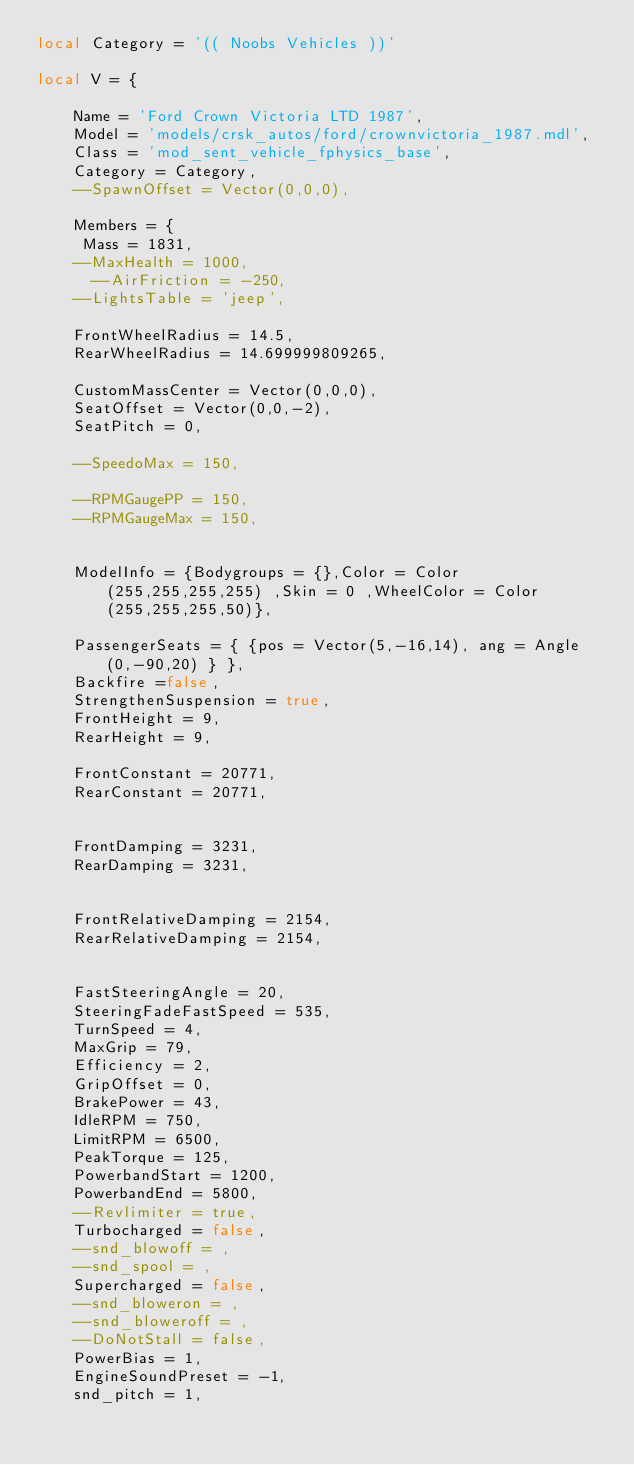Convert code to text. <code><loc_0><loc_0><loc_500><loc_500><_Lua_>local Category = '(( Noobs Vehicles ))'

local V = { 

    Name = 'Ford Crown Victoria LTD 1987',
    Model = 'models/crsk_autos/ford/crownvictoria_1987.mdl',
    Class = 'mod_sent_vehicle_fphysics_base',
    Category = Category,
    --SpawnOffset = Vector(0,0,0),

    Members = {
     Mass = 1831,
    --MaxHealth = 1000,
    	--AirFriction = -250,
    --LightsTable = 'jeep', 

    FrontWheelRadius = 14.5,
    RearWheelRadius = 14.699999809265,

    CustomMassCenter = Vector(0,0,0),
    SeatOffset = Vector(0,0,-2),
    SeatPitch = 0,

    --SpeedoMax = 150,

    --RPMGaugePP = 150,
    --RPMGaugeMax = 150,

    
    ModelInfo = {Bodygroups = {},Color = Color(255,255,255,255) ,Skin = 0 ,WheelColor = Color(255,255,255,50)},

    PassengerSeats = { {pos = Vector(5,-16,14), ang = Angle(0,-90,20) } },
    Backfire =false,
    StrengthenSuspension = true,
    FrontHeight = 9,
    RearHeight = 9,

    FrontConstant = 20771,
    RearConstant = 20771,


    FrontDamping = 3231,
    RearDamping = 3231,


    FrontRelativeDamping = 2154, 
    RearRelativeDamping = 2154,


    FastSteeringAngle = 20,
    SteeringFadeFastSpeed = 535,
    TurnSpeed = 4,
    MaxGrip = 79,
    Efficiency = 2,
    GripOffset = 0,
    BrakePower = 43,
    IdleRPM = 750,
    LimitRPM = 6500,
    PeakTorque = 125,
    PowerbandStart = 1200, 
    PowerbandEnd = 5800,
    --Revlimiter = true,
    Turbocharged = false,
    --snd_blowoff = , 
    --snd_spool = ,
    Supercharged = false,
    --snd_bloweron = ,
    --snd_bloweroff = ,
    --DoNotStall = false, 
    PowerBias = 1,	
    EngineSoundPreset = -1,
    snd_pitch = 1,</code> 